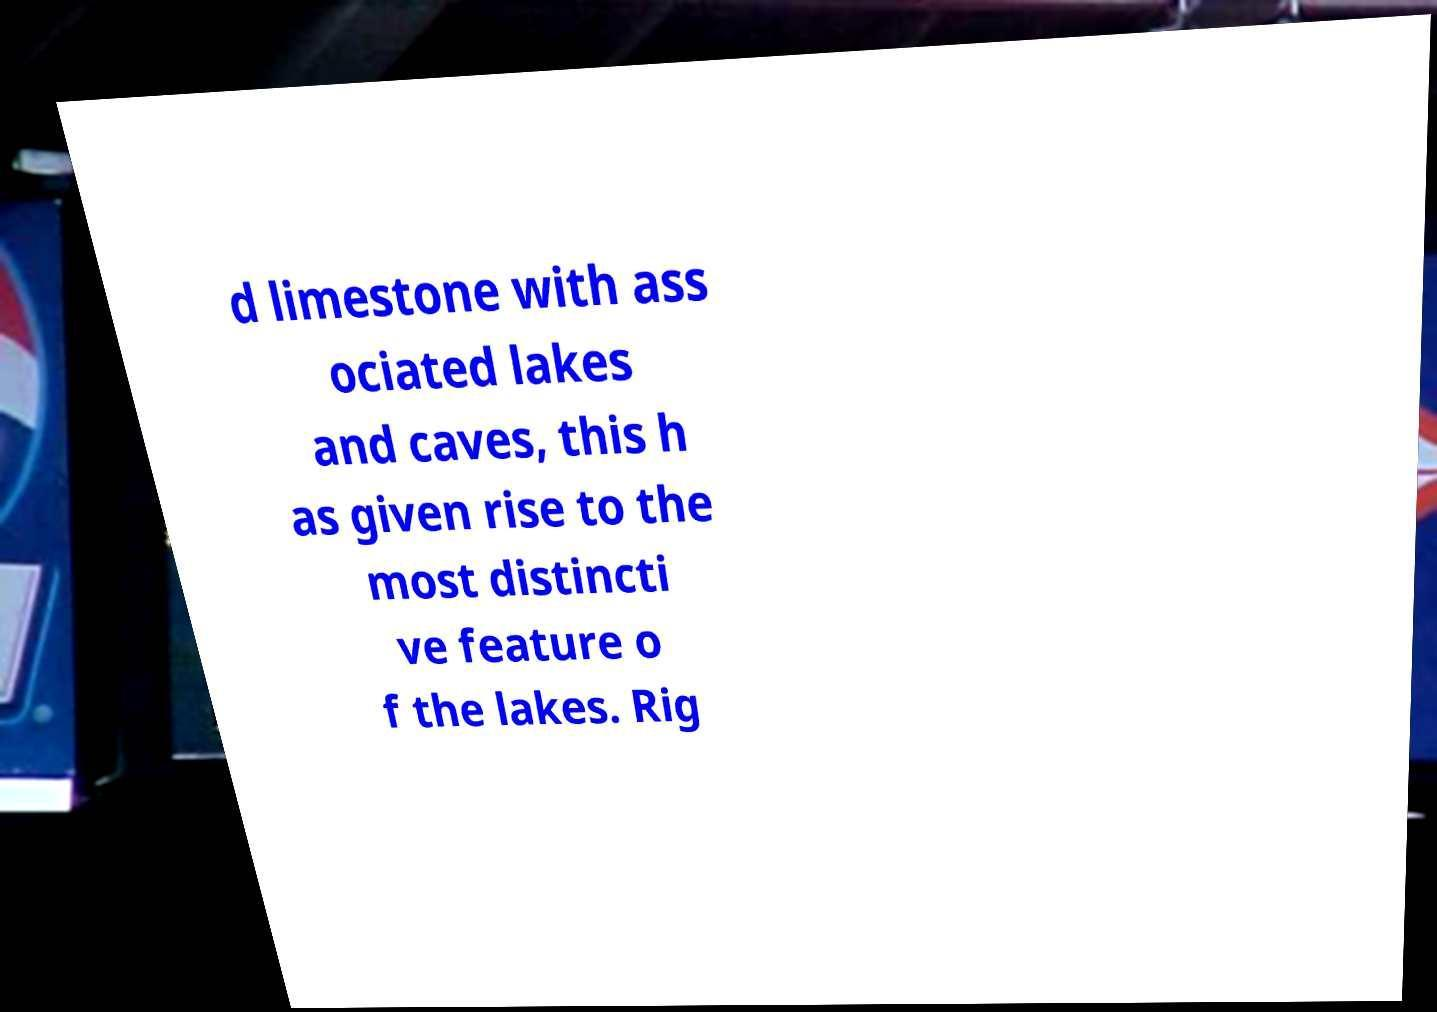Can you read and provide the text displayed in the image?This photo seems to have some interesting text. Can you extract and type it out for me? d limestone with ass ociated lakes and caves, this h as given rise to the most distincti ve feature o f the lakes. Rig 